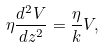Convert formula to latex. <formula><loc_0><loc_0><loc_500><loc_500>\eta \frac { d ^ { 2 } V } { d z ^ { 2 } } = \frac { \eta } { k } V ,</formula> 